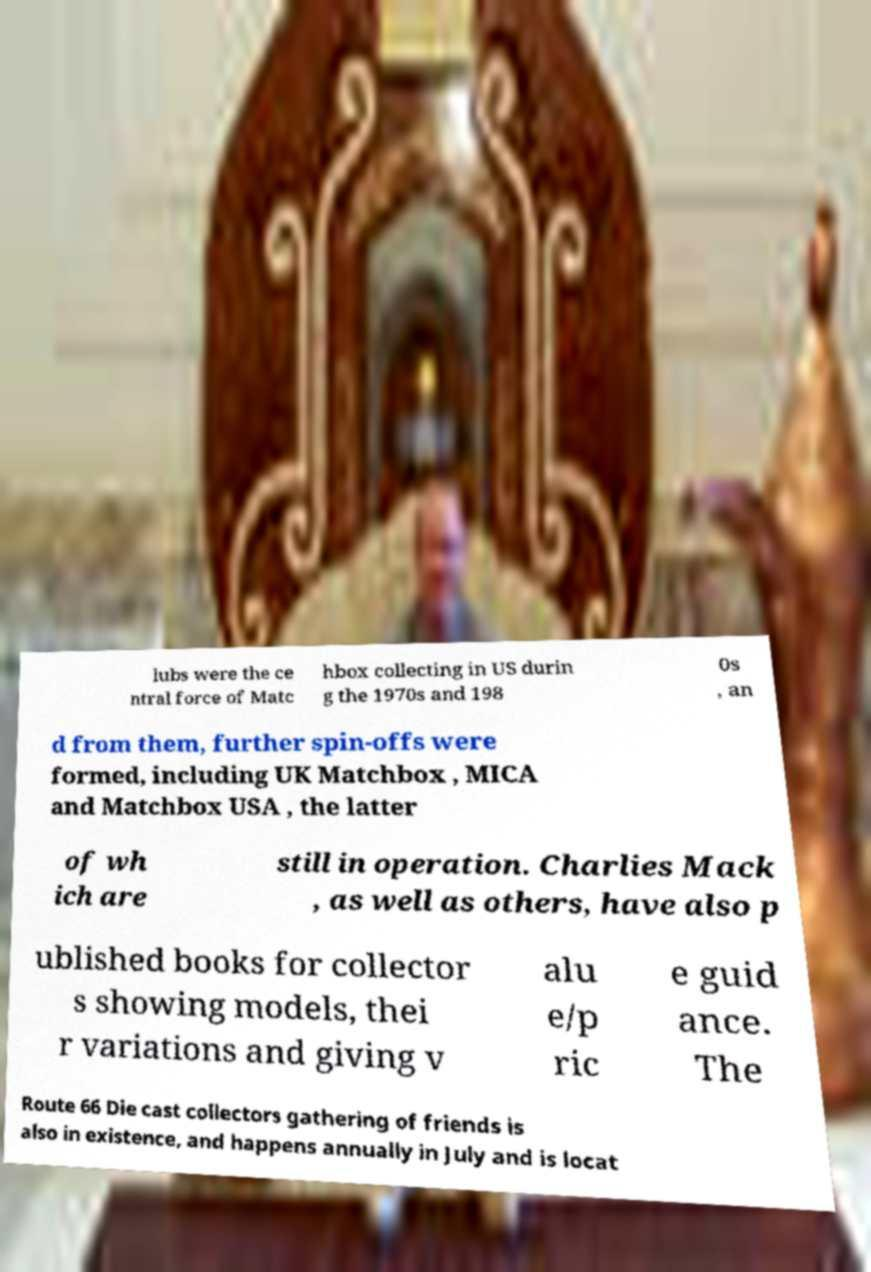Could you extract and type out the text from this image? lubs were the ce ntral force of Matc hbox collecting in US durin g the 1970s and 198 0s , an d from them, further spin-offs were formed, including UK Matchbox , MICA and Matchbox USA , the latter of wh ich are still in operation. Charlies Mack , as well as others, have also p ublished books for collector s showing models, thei r variations and giving v alu e/p ric e guid ance. The Route 66 Die cast collectors gathering of friends is also in existence, and happens annually in July and is locat 